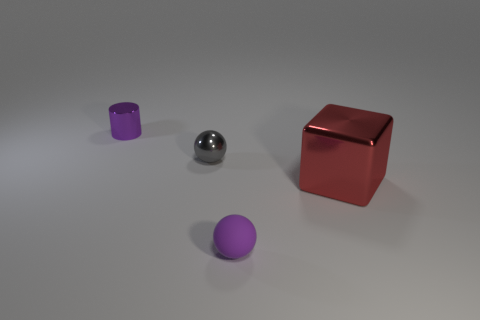How many cylinders are the same color as the small matte sphere?
Keep it short and to the point. 1. Is the red thing the same shape as the tiny purple metallic thing?
Make the answer very short. No. Is there anything else that is the same size as the block?
Your response must be concise. No. Is the number of matte spheres that are on the left side of the red thing greater than the number of gray things that are in front of the tiny metal sphere?
Your answer should be compact. Yes. Do the gray ball and the cylinder to the left of the gray sphere have the same material?
Offer a terse response. Yes. Is there any other thing that has the same shape as the big shiny object?
Make the answer very short. No. What is the color of the object that is to the right of the gray thing and behind the small matte object?
Provide a succinct answer. Red. What is the shape of the purple object in front of the big red metallic cube?
Your answer should be compact. Sphere. What size is the purple thing behind the purple thing in front of the shiny thing on the left side of the gray shiny thing?
Your response must be concise. Small. How many tiny purple matte spheres are behind the tiny purple object in front of the large thing?
Your answer should be very brief. 0. 